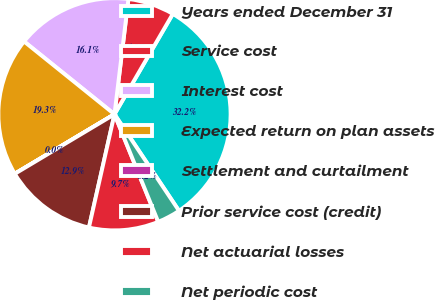<chart> <loc_0><loc_0><loc_500><loc_500><pie_chart><fcel>Years ended December 31<fcel>Service cost<fcel>Interest cost<fcel>Expected return on plan assets<fcel>Settlement and curtailment<fcel>Prior service cost (credit)<fcel>Net actuarial losses<fcel>Net periodic cost<nl><fcel>32.25%<fcel>6.46%<fcel>16.13%<fcel>19.35%<fcel>0.01%<fcel>12.9%<fcel>9.68%<fcel>3.23%<nl></chart> 